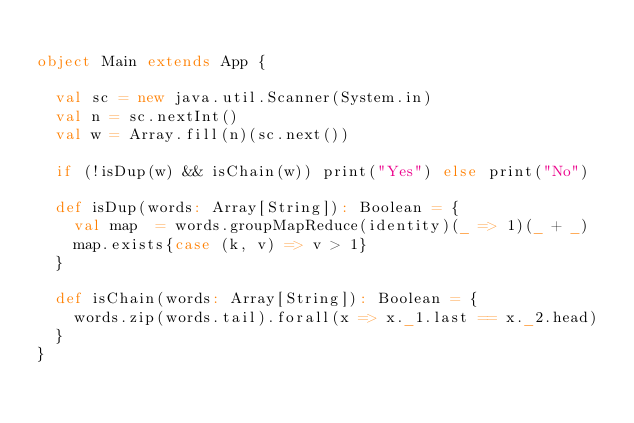Convert code to text. <code><loc_0><loc_0><loc_500><loc_500><_Scala_>
object Main extends App {
  
  val sc = new java.util.Scanner(System.in)
  val n = sc.nextInt()
  val w = Array.fill(n)(sc.next())
  
  if (!isDup(w) && isChain(w)) print("Yes") else print("No")
  
  def isDup(words: Array[String]): Boolean = {
    val map  = words.groupMapReduce(identity)(_ => 1)(_ + _)
    map.exists{case (k, v) => v > 1}
  }
  
  def isChain(words: Array[String]): Boolean = {
    words.zip(words.tail).forall(x => x._1.last == x._2.head)
  }
}</code> 